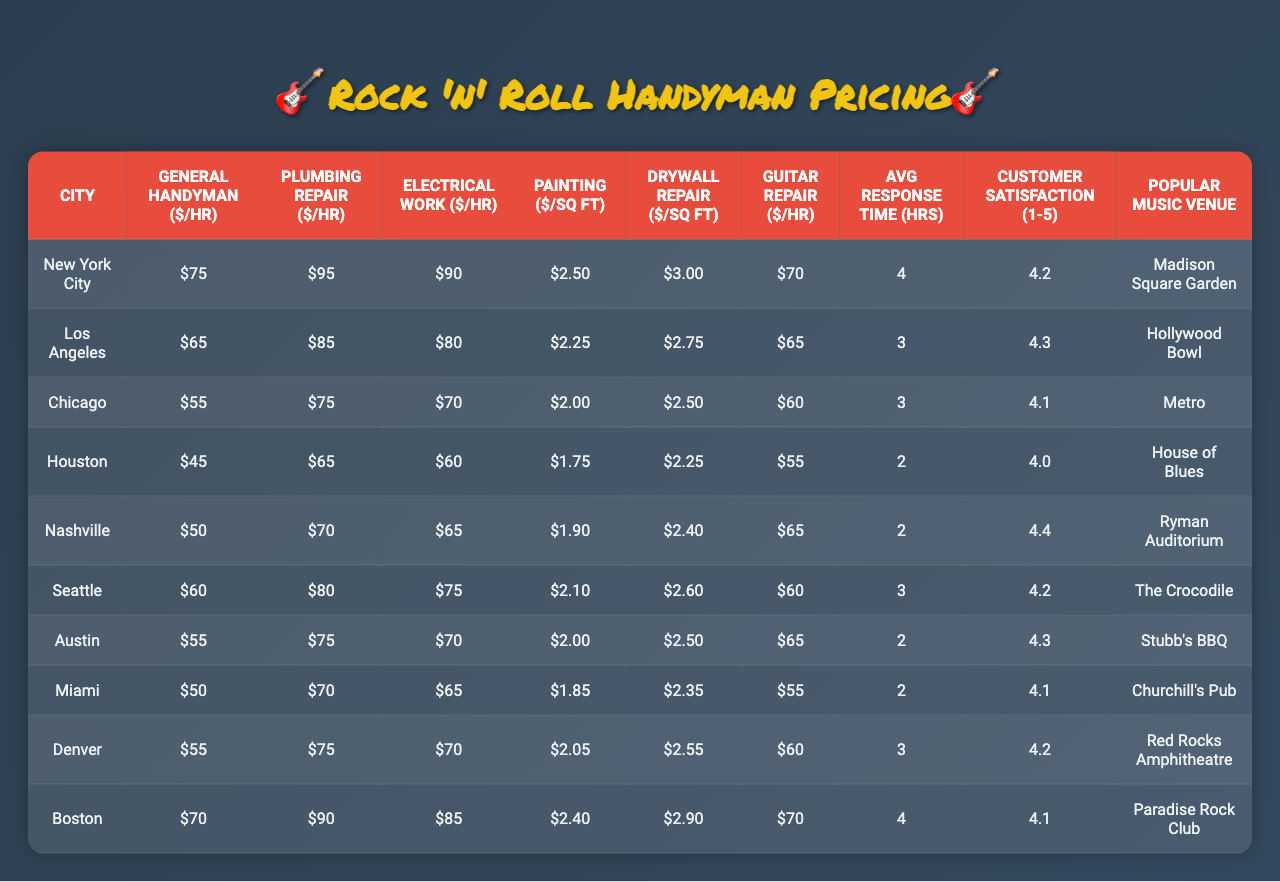What is the hourly rate for General Handyman services in New York City? The table lists New York City under the "City" column with the corresponding price of $75 under the "General Handyman ($/hour)" column. Therefore, the hourly rate for General Handyman services in New York City is $75.
Answer: $75 Which city has the highest Plumbing Repair hourly rate? By examining the "Plumbing Repair ($/hour)" column, the highest rate is found in New York City at $95. This is the maximum value when comparing the rates of all cities listed.
Answer: New York City What is the average hourly rate for Guitar Repair across all cities? To find the average of Guitar Repair rates, sum the rates: (70 + 65 + 60 + 55 + 65 + 60 + 65 + 55 + 60 + 70) =  685, then divide by 10, giving us 685 / 10 = 68.5.
Answer: 68.5 Which city has the lowest Electrical Work hourly rate? The "Electrical Work ($/hour)" column shows that Houston has the lowest hourly rate at $60, which is the minimum value among all cities listed.
Answer: Houston Calculate the difference in General Handyman rates between Los Angeles and Chicago. The General Handyman rate in Los Angeles is $65, and in Chicago, it's $55. Therefore, the difference is $65 - $55 = $10.
Answer: $10 Is the Customer Satisfaction rating in Austin higher than in Miami? Austin has a Customer Satisfaction rating of 4.3 while Miami has a rating of 4.1. Since 4.3 > 4.1, it confirms that Austin's rating is indeed higher than Miami's.
Answer: Yes What is the sum of the Painting rates per square foot for all cities? Adding the rates from the "Painting ($/sq ft)" column gives: 2.50 + 2.25 + 2.00 + 1.75 + 1.90 + 2.10 + 2.00 + 1.85 + 2.05 + 2.40 =  21.75.
Answer: 21.75 Which city has the fastest average response time? The "Average Response Time (hours)" column indicates that Houston has the fastest average response time of 2 hours, which is the lowest among all the cities listed.
Answer: Houston What is the median price for Drywall Repair across all cities? The Drywall Repair prices sorted are: 1.75, 2.00, 2.25, 2.35, 2.50, 2.50, 2.55, 2.60, 2.75, 2.90. The median is the average of the 5th and 6th values, (2.50 + 2.50) / 2 = 2.50.
Answer: 2.50 Is the Plumbing Repair hourly rate in Nashville higher than $70? Nashville's Plumbing Repair hourly rate is $70. Therefore, $70 is not higher than $70, making the answer false.
Answer: No 